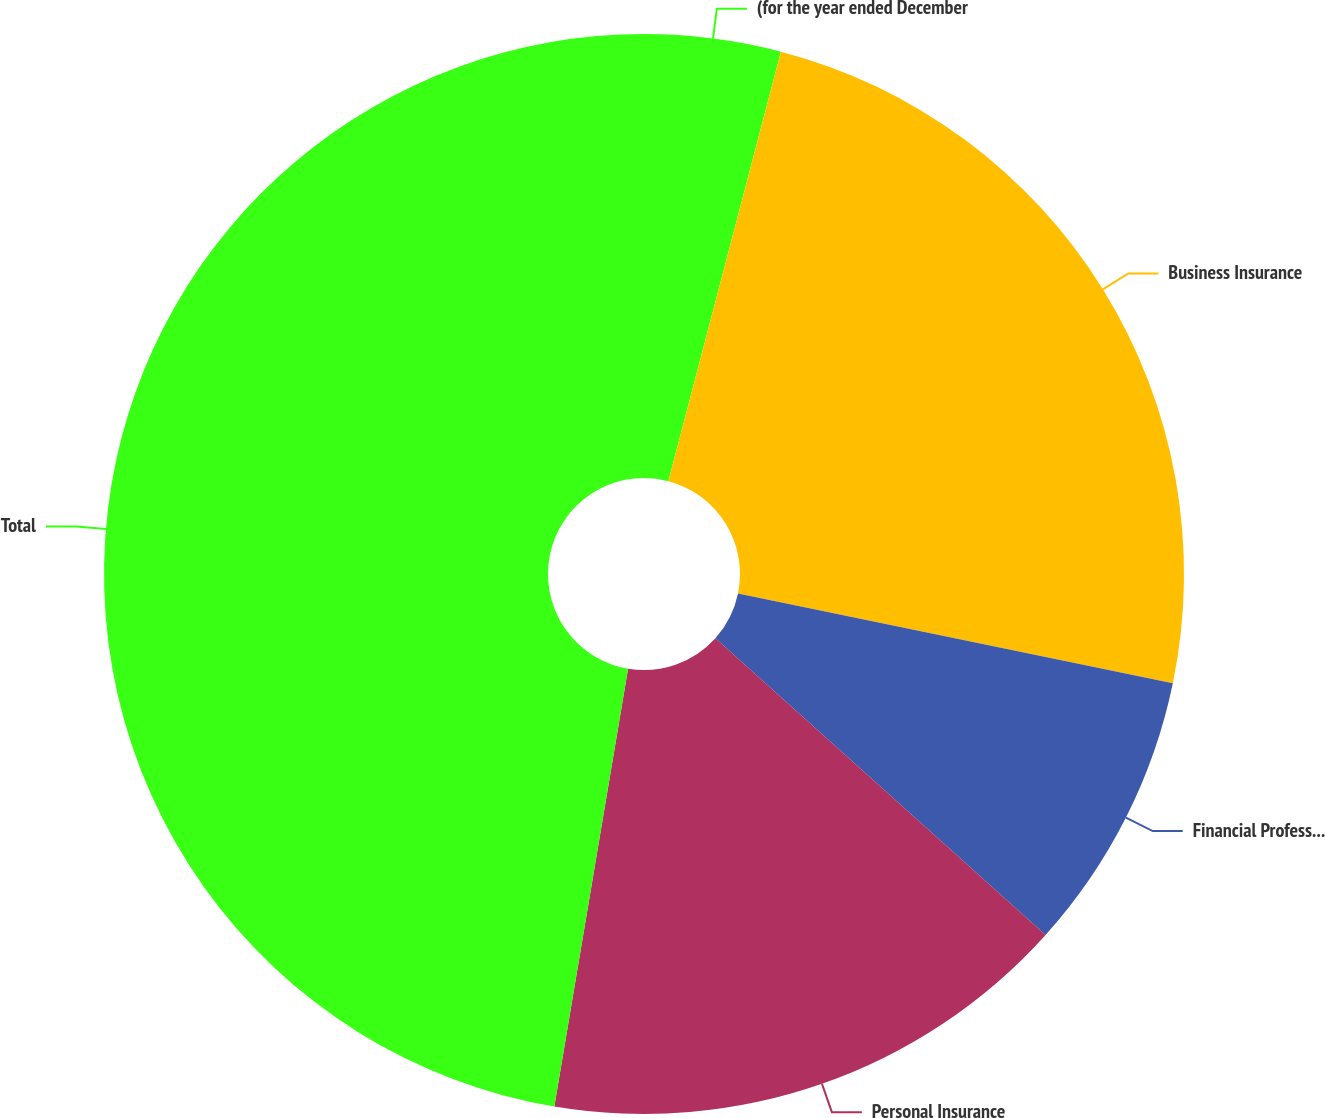Convert chart. <chart><loc_0><loc_0><loc_500><loc_500><pie_chart><fcel>(for the year ended December<fcel>Business Insurance<fcel>Financial Professional &<fcel>Personal Insurance<fcel>Total<nl><fcel>4.08%<fcel>24.16%<fcel>8.41%<fcel>16.0%<fcel>47.34%<nl></chart> 